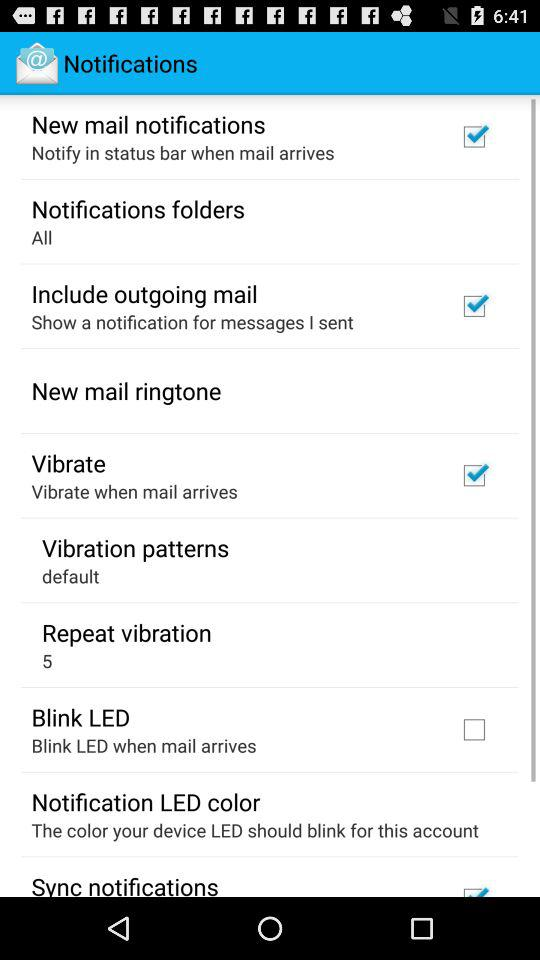What's the setting for "Repeat vibration"? The setting for "Repeat vibration" is 5. 